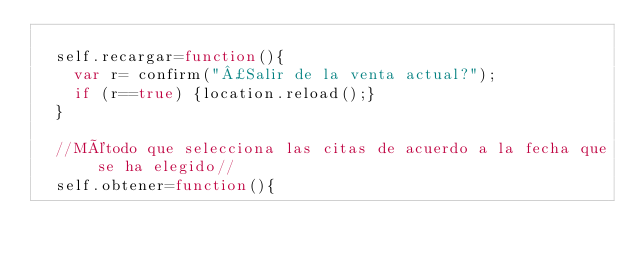<code> <loc_0><loc_0><loc_500><loc_500><_JavaScript_>
  self.recargar=function(){
    var r= confirm("¿Salir de la venta actual?");
    if (r==true) {location.reload();}
  }

  //Método que selecciona las citas de acuerdo a la fecha que se ha elegido//
  self.obtener=function(){</code> 